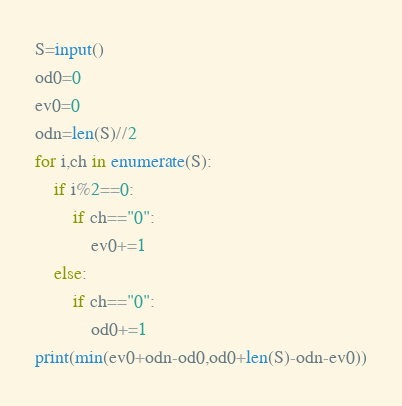Convert code to text. <code><loc_0><loc_0><loc_500><loc_500><_Python_>S=input()
od0=0
ev0=0
odn=len(S)//2
for i,ch in enumerate(S):
	if i%2==0:
		if ch=="0":
			ev0+=1
	else:
		if ch=="0":
			od0+=1
print(min(ev0+odn-od0,od0+len(S)-odn-ev0))</code> 